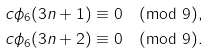Convert formula to latex. <formula><loc_0><loc_0><loc_500><loc_500>c \phi _ { 6 } ( 3 n + 1 ) & \equiv 0 \pmod { 9 } , \\ c \phi _ { 6 } ( 3 n + 2 ) & \equiv 0 \pmod { 9 } .</formula> 